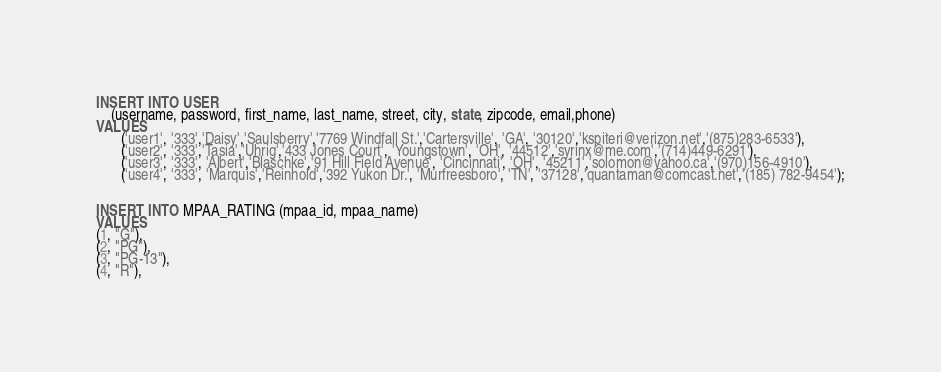Convert code to text. <code><loc_0><loc_0><loc_500><loc_500><_SQL_>INSERT INTO USER
    (username, password, first_name, last_name, street, city, state, zipcode, email,phone)
VALUES
       ('user1', '333','Daisy','Saulsberry','7769 Windfall St.','Cartersville', 'GA', '30120','kspiteri@verizon.net','(875)283-6533'),
       ('user2', '333','Tasia','Uhrig','433 Jones Court', 'Youngstown', 'OH', '44512','syrinx@me.com','(714)449-6291'),
       ('user3', '333', 'Albert','Blaschke','91 Hill Field Avenue', 'Cincinnati', 'OH', '45211','solomon@yahoo.ca','(970)156-4910'),
       ('user4', '333', 'Marquis','Reinhold','392 Yukon Dr.', 'Murfreesboro', 'TN', '37128','quantaman@comcast.net','(185) 782-9454');


INSERT INTO MPAA_RATING (mpaa_id, mpaa_name)
VALUES
(1, "G"),
(2, "PG"),
(3, "PG-13"),
(4, "R"),</code> 